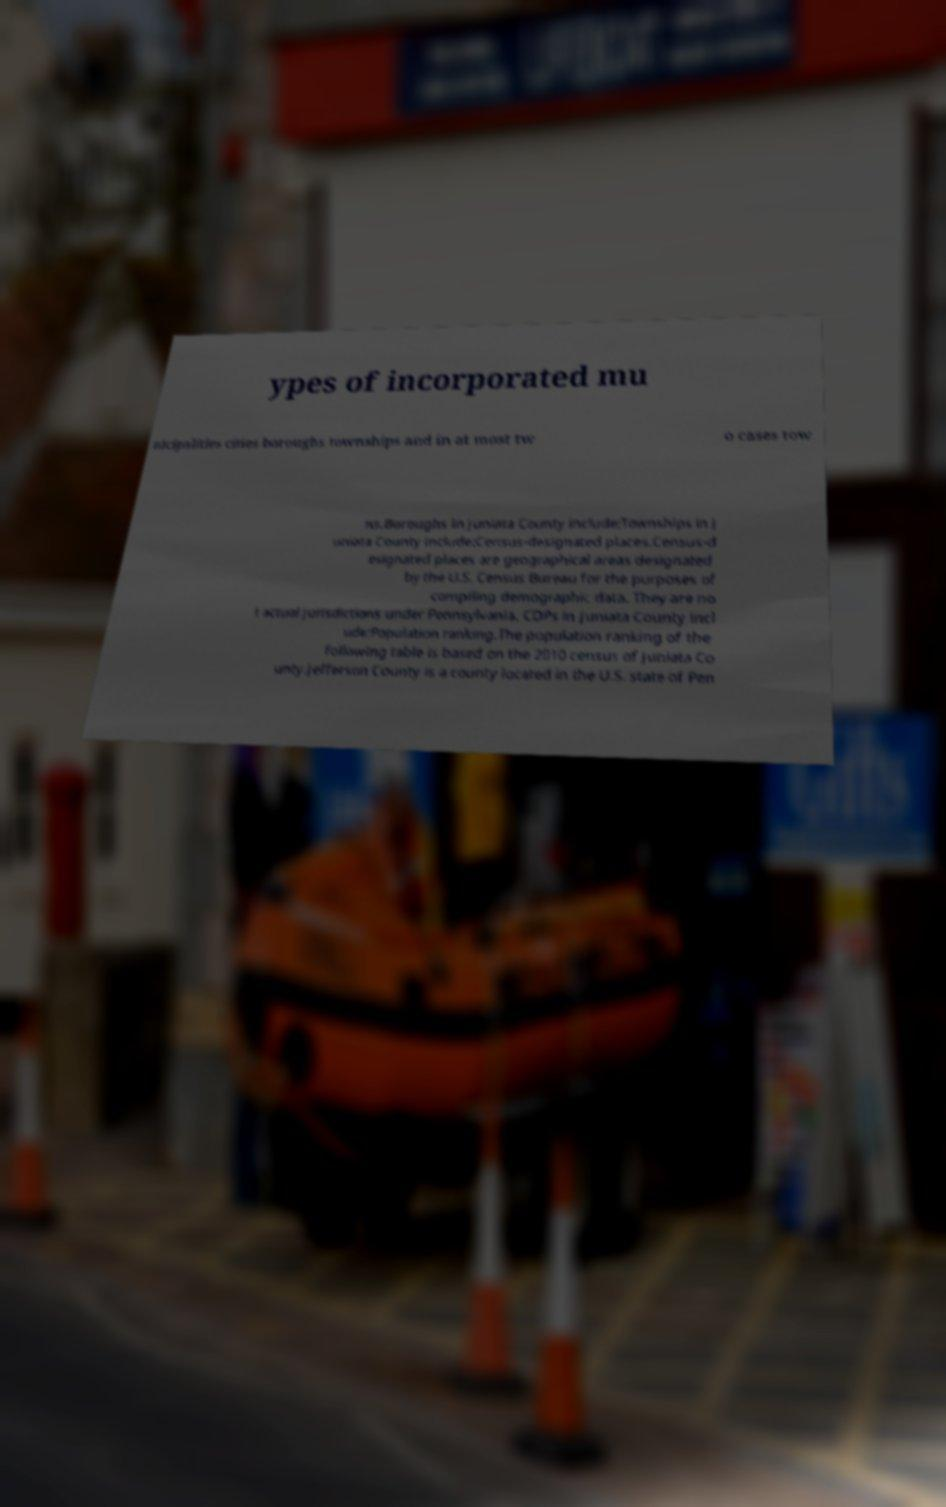Can you accurately transcribe the text from the provided image for me? ypes of incorporated mu nicipalities cities boroughs townships and in at most tw o cases tow ns.Boroughs in Juniata County include:Townships in J uniata County include:Census-designated places.Census-d esignated places are geographical areas designated by the U.S. Census Bureau for the purposes of compiling demographic data. They are no t actual jurisdictions under Pennsylvania. CDPs in Juniata County incl ude:Population ranking.The population ranking of the following table is based on the 2010 census of Juniata Co unty.Jefferson County is a county located in the U.S. state of Pen 